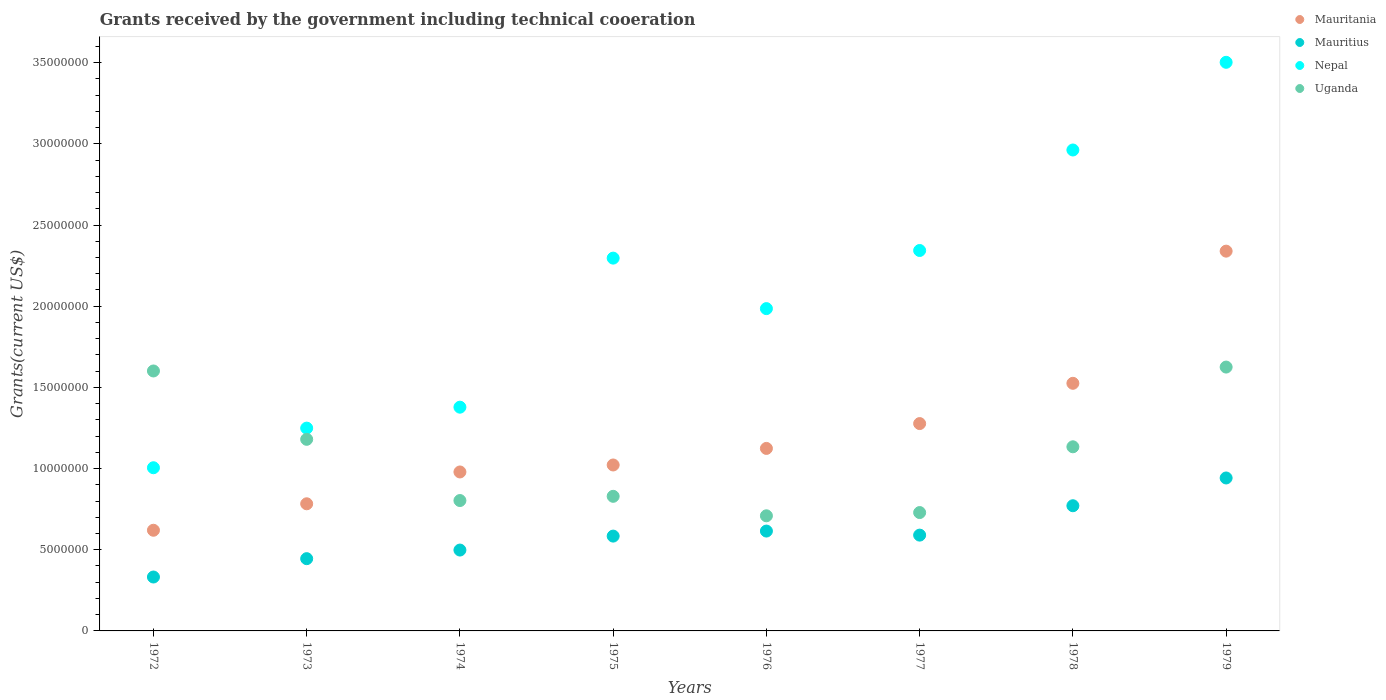What is the total grants received by the government in Nepal in 1973?
Keep it short and to the point. 1.25e+07. Across all years, what is the maximum total grants received by the government in Mauritania?
Provide a succinct answer. 2.34e+07. Across all years, what is the minimum total grants received by the government in Nepal?
Your response must be concise. 1.00e+07. In which year was the total grants received by the government in Uganda maximum?
Your response must be concise. 1979. In which year was the total grants received by the government in Uganda minimum?
Keep it short and to the point. 1976. What is the total total grants received by the government in Uganda in the graph?
Your answer should be compact. 8.61e+07. What is the difference between the total grants received by the government in Mauritius in 1974 and that in 1977?
Your answer should be compact. -9.20e+05. What is the difference between the total grants received by the government in Mauritania in 1979 and the total grants received by the government in Mauritius in 1975?
Ensure brevity in your answer.  1.76e+07. What is the average total grants received by the government in Mauritania per year?
Make the answer very short. 1.21e+07. In the year 1972, what is the difference between the total grants received by the government in Mauritania and total grants received by the government in Mauritius?
Your answer should be very brief. 2.88e+06. What is the ratio of the total grants received by the government in Mauritius in 1975 to that in 1978?
Ensure brevity in your answer.  0.76. Is the total grants received by the government in Nepal in 1972 less than that in 1977?
Ensure brevity in your answer.  Yes. What is the difference between the highest and the second highest total grants received by the government in Nepal?
Give a very brief answer. 5.40e+06. What is the difference between the highest and the lowest total grants received by the government in Mauritius?
Offer a terse response. 6.10e+06. Is the sum of the total grants received by the government in Mauritania in 1976 and 1978 greater than the maximum total grants received by the government in Mauritius across all years?
Give a very brief answer. Yes. Is it the case that in every year, the sum of the total grants received by the government in Mauritania and total grants received by the government in Mauritius  is greater than the total grants received by the government in Uganda?
Give a very brief answer. No. Does the total grants received by the government in Mauritius monotonically increase over the years?
Offer a very short reply. No. Is the total grants received by the government in Mauritania strictly less than the total grants received by the government in Nepal over the years?
Ensure brevity in your answer.  Yes. How many dotlines are there?
Provide a short and direct response. 4. How many years are there in the graph?
Your answer should be compact. 8. Are the values on the major ticks of Y-axis written in scientific E-notation?
Offer a terse response. No. Does the graph contain any zero values?
Make the answer very short. No. Does the graph contain grids?
Your answer should be very brief. No. Where does the legend appear in the graph?
Offer a terse response. Top right. How many legend labels are there?
Provide a short and direct response. 4. What is the title of the graph?
Your answer should be compact. Grants received by the government including technical cooeration. Does "Low & middle income" appear as one of the legend labels in the graph?
Your answer should be compact. No. What is the label or title of the X-axis?
Offer a terse response. Years. What is the label or title of the Y-axis?
Your answer should be compact. Grants(current US$). What is the Grants(current US$) of Mauritania in 1972?
Offer a very short reply. 6.20e+06. What is the Grants(current US$) of Mauritius in 1972?
Give a very brief answer. 3.32e+06. What is the Grants(current US$) in Nepal in 1972?
Your response must be concise. 1.00e+07. What is the Grants(current US$) in Uganda in 1972?
Give a very brief answer. 1.60e+07. What is the Grants(current US$) of Mauritania in 1973?
Provide a succinct answer. 7.83e+06. What is the Grants(current US$) in Mauritius in 1973?
Offer a very short reply. 4.45e+06. What is the Grants(current US$) of Nepal in 1973?
Provide a short and direct response. 1.25e+07. What is the Grants(current US$) in Uganda in 1973?
Offer a terse response. 1.18e+07. What is the Grants(current US$) in Mauritania in 1974?
Offer a terse response. 9.79e+06. What is the Grants(current US$) in Mauritius in 1974?
Ensure brevity in your answer.  4.98e+06. What is the Grants(current US$) in Nepal in 1974?
Ensure brevity in your answer.  1.38e+07. What is the Grants(current US$) in Uganda in 1974?
Your answer should be compact. 8.03e+06. What is the Grants(current US$) of Mauritania in 1975?
Your answer should be very brief. 1.02e+07. What is the Grants(current US$) in Mauritius in 1975?
Keep it short and to the point. 5.84e+06. What is the Grants(current US$) in Nepal in 1975?
Your answer should be very brief. 2.30e+07. What is the Grants(current US$) of Uganda in 1975?
Your answer should be compact. 8.29e+06. What is the Grants(current US$) in Mauritania in 1976?
Provide a succinct answer. 1.12e+07. What is the Grants(current US$) in Mauritius in 1976?
Provide a short and direct response. 6.15e+06. What is the Grants(current US$) in Nepal in 1976?
Offer a very short reply. 1.98e+07. What is the Grants(current US$) in Uganda in 1976?
Ensure brevity in your answer.  7.09e+06. What is the Grants(current US$) in Mauritania in 1977?
Your answer should be very brief. 1.28e+07. What is the Grants(current US$) in Mauritius in 1977?
Your answer should be very brief. 5.90e+06. What is the Grants(current US$) in Nepal in 1977?
Give a very brief answer. 2.34e+07. What is the Grants(current US$) of Uganda in 1977?
Offer a very short reply. 7.29e+06. What is the Grants(current US$) of Mauritania in 1978?
Offer a very short reply. 1.52e+07. What is the Grants(current US$) of Mauritius in 1978?
Provide a short and direct response. 7.71e+06. What is the Grants(current US$) in Nepal in 1978?
Offer a terse response. 2.96e+07. What is the Grants(current US$) of Uganda in 1978?
Provide a short and direct response. 1.13e+07. What is the Grants(current US$) of Mauritania in 1979?
Give a very brief answer. 2.34e+07. What is the Grants(current US$) in Mauritius in 1979?
Provide a succinct answer. 9.42e+06. What is the Grants(current US$) in Nepal in 1979?
Make the answer very short. 3.50e+07. What is the Grants(current US$) of Uganda in 1979?
Provide a short and direct response. 1.62e+07. Across all years, what is the maximum Grants(current US$) of Mauritania?
Give a very brief answer. 2.34e+07. Across all years, what is the maximum Grants(current US$) of Mauritius?
Your answer should be very brief. 9.42e+06. Across all years, what is the maximum Grants(current US$) in Nepal?
Offer a very short reply. 3.50e+07. Across all years, what is the maximum Grants(current US$) of Uganda?
Provide a short and direct response. 1.62e+07. Across all years, what is the minimum Grants(current US$) of Mauritania?
Keep it short and to the point. 6.20e+06. Across all years, what is the minimum Grants(current US$) of Mauritius?
Give a very brief answer. 3.32e+06. Across all years, what is the minimum Grants(current US$) of Nepal?
Provide a short and direct response. 1.00e+07. Across all years, what is the minimum Grants(current US$) in Uganda?
Keep it short and to the point. 7.09e+06. What is the total Grants(current US$) in Mauritania in the graph?
Ensure brevity in your answer.  9.67e+07. What is the total Grants(current US$) of Mauritius in the graph?
Your answer should be compact. 4.78e+07. What is the total Grants(current US$) in Nepal in the graph?
Provide a succinct answer. 1.67e+08. What is the total Grants(current US$) of Uganda in the graph?
Your response must be concise. 8.61e+07. What is the difference between the Grants(current US$) in Mauritania in 1972 and that in 1973?
Ensure brevity in your answer.  -1.63e+06. What is the difference between the Grants(current US$) of Mauritius in 1972 and that in 1973?
Offer a terse response. -1.13e+06. What is the difference between the Grants(current US$) of Nepal in 1972 and that in 1973?
Keep it short and to the point. -2.44e+06. What is the difference between the Grants(current US$) in Uganda in 1972 and that in 1973?
Offer a terse response. 4.21e+06. What is the difference between the Grants(current US$) in Mauritania in 1972 and that in 1974?
Ensure brevity in your answer.  -3.59e+06. What is the difference between the Grants(current US$) of Mauritius in 1972 and that in 1974?
Your answer should be compact. -1.66e+06. What is the difference between the Grants(current US$) of Nepal in 1972 and that in 1974?
Keep it short and to the point. -3.73e+06. What is the difference between the Grants(current US$) in Uganda in 1972 and that in 1974?
Your answer should be compact. 7.98e+06. What is the difference between the Grants(current US$) of Mauritania in 1972 and that in 1975?
Give a very brief answer. -4.02e+06. What is the difference between the Grants(current US$) of Mauritius in 1972 and that in 1975?
Offer a terse response. -2.52e+06. What is the difference between the Grants(current US$) in Nepal in 1972 and that in 1975?
Give a very brief answer. -1.29e+07. What is the difference between the Grants(current US$) of Uganda in 1972 and that in 1975?
Provide a succinct answer. 7.72e+06. What is the difference between the Grants(current US$) in Mauritania in 1972 and that in 1976?
Offer a very short reply. -5.04e+06. What is the difference between the Grants(current US$) of Mauritius in 1972 and that in 1976?
Provide a succinct answer. -2.83e+06. What is the difference between the Grants(current US$) in Nepal in 1972 and that in 1976?
Offer a terse response. -9.80e+06. What is the difference between the Grants(current US$) of Uganda in 1972 and that in 1976?
Offer a very short reply. 8.92e+06. What is the difference between the Grants(current US$) of Mauritania in 1972 and that in 1977?
Your answer should be compact. -6.57e+06. What is the difference between the Grants(current US$) of Mauritius in 1972 and that in 1977?
Give a very brief answer. -2.58e+06. What is the difference between the Grants(current US$) in Nepal in 1972 and that in 1977?
Provide a short and direct response. -1.34e+07. What is the difference between the Grants(current US$) in Uganda in 1972 and that in 1977?
Your answer should be compact. 8.72e+06. What is the difference between the Grants(current US$) in Mauritania in 1972 and that in 1978?
Give a very brief answer. -9.05e+06. What is the difference between the Grants(current US$) in Mauritius in 1972 and that in 1978?
Your answer should be compact. -4.39e+06. What is the difference between the Grants(current US$) in Nepal in 1972 and that in 1978?
Your answer should be compact. -1.96e+07. What is the difference between the Grants(current US$) of Uganda in 1972 and that in 1978?
Your answer should be very brief. 4.67e+06. What is the difference between the Grants(current US$) in Mauritania in 1972 and that in 1979?
Ensure brevity in your answer.  -1.72e+07. What is the difference between the Grants(current US$) of Mauritius in 1972 and that in 1979?
Keep it short and to the point. -6.10e+06. What is the difference between the Grants(current US$) in Nepal in 1972 and that in 1979?
Your answer should be compact. -2.50e+07. What is the difference between the Grants(current US$) in Uganda in 1972 and that in 1979?
Your answer should be very brief. -2.40e+05. What is the difference between the Grants(current US$) in Mauritania in 1973 and that in 1974?
Make the answer very short. -1.96e+06. What is the difference between the Grants(current US$) of Mauritius in 1973 and that in 1974?
Offer a terse response. -5.30e+05. What is the difference between the Grants(current US$) of Nepal in 1973 and that in 1974?
Your answer should be compact. -1.29e+06. What is the difference between the Grants(current US$) of Uganda in 1973 and that in 1974?
Offer a very short reply. 3.77e+06. What is the difference between the Grants(current US$) of Mauritania in 1973 and that in 1975?
Offer a very short reply. -2.39e+06. What is the difference between the Grants(current US$) of Mauritius in 1973 and that in 1975?
Provide a succinct answer. -1.39e+06. What is the difference between the Grants(current US$) of Nepal in 1973 and that in 1975?
Keep it short and to the point. -1.05e+07. What is the difference between the Grants(current US$) in Uganda in 1973 and that in 1975?
Provide a short and direct response. 3.51e+06. What is the difference between the Grants(current US$) of Mauritania in 1973 and that in 1976?
Make the answer very short. -3.41e+06. What is the difference between the Grants(current US$) of Mauritius in 1973 and that in 1976?
Your answer should be very brief. -1.70e+06. What is the difference between the Grants(current US$) in Nepal in 1973 and that in 1976?
Offer a terse response. -7.36e+06. What is the difference between the Grants(current US$) in Uganda in 1973 and that in 1976?
Provide a succinct answer. 4.71e+06. What is the difference between the Grants(current US$) of Mauritania in 1973 and that in 1977?
Provide a succinct answer. -4.94e+06. What is the difference between the Grants(current US$) of Mauritius in 1973 and that in 1977?
Keep it short and to the point. -1.45e+06. What is the difference between the Grants(current US$) of Nepal in 1973 and that in 1977?
Your response must be concise. -1.09e+07. What is the difference between the Grants(current US$) of Uganda in 1973 and that in 1977?
Your answer should be compact. 4.51e+06. What is the difference between the Grants(current US$) of Mauritania in 1973 and that in 1978?
Give a very brief answer. -7.42e+06. What is the difference between the Grants(current US$) of Mauritius in 1973 and that in 1978?
Your response must be concise. -3.26e+06. What is the difference between the Grants(current US$) in Nepal in 1973 and that in 1978?
Offer a very short reply. -1.71e+07. What is the difference between the Grants(current US$) in Uganda in 1973 and that in 1978?
Offer a terse response. 4.60e+05. What is the difference between the Grants(current US$) in Mauritania in 1973 and that in 1979?
Provide a short and direct response. -1.56e+07. What is the difference between the Grants(current US$) in Mauritius in 1973 and that in 1979?
Keep it short and to the point. -4.97e+06. What is the difference between the Grants(current US$) in Nepal in 1973 and that in 1979?
Keep it short and to the point. -2.25e+07. What is the difference between the Grants(current US$) of Uganda in 1973 and that in 1979?
Provide a short and direct response. -4.45e+06. What is the difference between the Grants(current US$) of Mauritania in 1974 and that in 1975?
Your response must be concise. -4.30e+05. What is the difference between the Grants(current US$) of Mauritius in 1974 and that in 1975?
Offer a very short reply. -8.60e+05. What is the difference between the Grants(current US$) in Nepal in 1974 and that in 1975?
Give a very brief answer. -9.18e+06. What is the difference between the Grants(current US$) in Mauritania in 1974 and that in 1976?
Your answer should be compact. -1.45e+06. What is the difference between the Grants(current US$) in Mauritius in 1974 and that in 1976?
Offer a very short reply. -1.17e+06. What is the difference between the Grants(current US$) of Nepal in 1974 and that in 1976?
Offer a terse response. -6.07e+06. What is the difference between the Grants(current US$) of Uganda in 1974 and that in 1976?
Keep it short and to the point. 9.40e+05. What is the difference between the Grants(current US$) in Mauritania in 1974 and that in 1977?
Provide a short and direct response. -2.98e+06. What is the difference between the Grants(current US$) of Mauritius in 1974 and that in 1977?
Ensure brevity in your answer.  -9.20e+05. What is the difference between the Grants(current US$) of Nepal in 1974 and that in 1977?
Provide a short and direct response. -9.65e+06. What is the difference between the Grants(current US$) in Uganda in 1974 and that in 1977?
Offer a terse response. 7.40e+05. What is the difference between the Grants(current US$) in Mauritania in 1974 and that in 1978?
Give a very brief answer. -5.46e+06. What is the difference between the Grants(current US$) in Mauritius in 1974 and that in 1978?
Offer a terse response. -2.73e+06. What is the difference between the Grants(current US$) of Nepal in 1974 and that in 1978?
Your response must be concise. -1.58e+07. What is the difference between the Grants(current US$) in Uganda in 1974 and that in 1978?
Your response must be concise. -3.31e+06. What is the difference between the Grants(current US$) in Mauritania in 1974 and that in 1979?
Your answer should be very brief. -1.36e+07. What is the difference between the Grants(current US$) in Mauritius in 1974 and that in 1979?
Your answer should be compact. -4.44e+06. What is the difference between the Grants(current US$) of Nepal in 1974 and that in 1979?
Offer a terse response. -2.12e+07. What is the difference between the Grants(current US$) of Uganda in 1974 and that in 1979?
Offer a terse response. -8.22e+06. What is the difference between the Grants(current US$) in Mauritania in 1975 and that in 1976?
Provide a succinct answer. -1.02e+06. What is the difference between the Grants(current US$) in Mauritius in 1975 and that in 1976?
Make the answer very short. -3.10e+05. What is the difference between the Grants(current US$) of Nepal in 1975 and that in 1976?
Your response must be concise. 3.11e+06. What is the difference between the Grants(current US$) in Uganda in 1975 and that in 1976?
Ensure brevity in your answer.  1.20e+06. What is the difference between the Grants(current US$) of Mauritania in 1975 and that in 1977?
Offer a very short reply. -2.55e+06. What is the difference between the Grants(current US$) in Mauritius in 1975 and that in 1977?
Give a very brief answer. -6.00e+04. What is the difference between the Grants(current US$) of Nepal in 1975 and that in 1977?
Provide a succinct answer. -4.70e+05. What is the difference between the Grants(current US$) in Uganda in 1975 and that in 1977?
Provide a short and direct response. 1.00e+06. What is the difference between the Grants(current US$) of Mauritania in 1975 and that in 1978?
Offer a terse response. -5.03e+06. What is the difference between the Grants(current US$) of Mauritius in 1975 and that in 1978?
Offer a terse response. -1.87e+06. What is the difference between the Grants(current US$) of Nepal in 1975 and that in 1978?
Make the answer very short. -6.66e+06. What is the difference between the Grants(current US$) of Uganda in 1975 and that in 1978?
Your answer should be very brief. -3.05e+06. What is the difference between the Grants(current US$) of Mauritania in 1975 and that in 1979?
Offer a very short reply. -1.32e+07. What is the difference between the Grants(current US$) in Mauritius in 1975 and that in 1979?
Ensure brevity in your answer.  -3.58e+06. What is the difference between the Grants(current US$) in Nepal in 1975 and that in 1979?
Your answer should be very brief. -1.21e+07. What is the difference between the Grants(current US$) in Uganda in 1975 and that in 1979?
Your answer should be very brief. -7.96e+06. What is the difference between the Grants(current US$) in Mauritania in 1976 and that in 1977?
Provide a succinct answer. -1.53e+06. What is the difference between the Grants(current US$) of Nepal in 1976 and that in 1977?
Ensure brevity in your answer.  -3.58e+06. What is the difference between the Grants(current US$) of Mauritania in 1976 and that in 1978?
Provide a short and direct response. -4.01e+06. What is the difference between the Grants(current US$) of Mauritius in 1976 and that in 1978?
Offer a terse response. -1.56e+06. What is the difference between the Grants(current US$) in Nepal in 1976 and that in 1978?
Offer a very short reply. -9.77e+06. What is the difference between the Grants(current US$) of Uganda in 1976 and that in 1978?
Your response must be concise. -4.25e+06. What is the difference between the Grants(current US$) in Mauritania in 1976 and that in 1979?
Give a very brief answer. -1.22e+07. What is the difference between the Grants(current US$) of Mauritius in 1976 and that in 1979?
Your answer should be very brief. -3.27e+06. What is the difference between the Grants(current US$) of Nepal in 1976 and that in 1979?
Provide a short and direct response. -1.52e+07. What is the difference between the Grants(current US$) of Uganda in 1976 and that in 1979?
Your response must be concise. -9.16e+06. What is the difference between the Grants(current US$) in Mauritania in 1977 and that in 1978?
Your answer should be very brief. -2.48e+06. What is the difference between the Grants(current US$) in Mauritius in 1977 and that in 1978?
Your answer should be compact. -1.81e+06. What is the difference between the Grants(current US$) in Nepal in 1977 and that in 1978?
Offer a very short reply. -6.19e+06. What is the difference between the Grants(current US$) in Uganda in 1977 and that in 1978?
Your answer should be compact. -4.05e+06. What is the difference between the Grants(current US$) in Mauritania in 1977 and that in 1979?
Offer a terse response. -1.06e+07. What is the difference between the Grants(current US$) of Mauritius in 1977 and that in 1979?
Keep it short and to the point. -3.52e+06. What is the difference between the Grants(current US$) of Nepal in 1977 and that in 1979?
Your answer should be very brief. -1.16e+07. What is the difference between the Grants(current US$) of Uganda in 1977 and that in 1979?
Provide a short and direct response. -8.96e+06. What is the difference between the Grants(current US$) in Mauritania in 1978 and that in 1979?
Offer a terse response. -8.14e+06. What is the difference between the Grants(current US$) in Mauritius in 1978 and that in 1979?
Ensure brevity in your answer.  -1.71e+06. What is the difference between the Grants(current US$) of Nepal in 1978 and that in 1979?
Your answer should be very brief. -5.40e+06. What is the difference between the Grants(current US$) in Uganda in 1978 and that in 1979?
Provide a succinct answer. -4.91e+06. What is the difference between the Grants(current US$) of Mauritania in 1972 and the Grants(current US$) of Mauritius in 1973?
Offer a very short reply. 1.75e+06. What is the difference between the Grants(current US$) in Mauritania in 1972 and the Grants(current US$) in Nepal in 1973?
Make the answer very short. -6.29e+06. What is the difference between the Grants(current US$) of Mauritania in 1972 and the Grants(current US$) of Uganda in 1973?
Your answer should be very brief. -5.60e+06. What is the difference between the Grants(current US$) in Mauritius in 1972 and the Grants(current US$) in Nepal in 1973?
Give a very brief answer. -9.17e+06. What is the difference between the Grants(current US$) of Mauritius in 1972 and the Grants(current US$) of Uganda in 1973?
Your answer should be very brief. -8.48e+06. What is the difference between the Grants(current US$) of Nepal in 1972 and the Grants(current US$) of Uganda in 1973?
Your answer should be compact. -1.75e+06. What is the difference between the Grants(current US$) in Mauritania in 1972 and the Grants(current US$) in Mauritius in 1974?
Provide a succinct answer. 1.22e+06. What is the difference between the Grants(current US$) in Mauritania in 1972 and the Grants(current US$) in Nepal in 1974?
Offer a terse response. -7.58e+06. What is the difference between the Grants(current US$) of Mauritania in 1972 and the Grants(current US$) of Uganda in 1974?
Your answer should be very brief. -1.83e+06. What is the difference between the Grants(current US$) in Mauritius in 1972 and the Grants(current US$) in Nepal in 1974?
Give a very brief answer. -1.05e+07. What is the difference between the Grants(current US$) of Mauritius in 1972 and the Grants(current US$) of Uganda in 1974?
Give a very brief answer. -4.71e+06. What is the difference between the Grants(current US$) in Nepal in 1972 and the Grants(current US$) in Uganda in 1974?
Provide a short and direct response. 2.02e+06. What is the difference between the Grants(current US$) of Mauritania in 1972 and the Grants(current US$) of Mauritius in 1975?
Your answer should be compact. 3.60e+05. What is the difference between the Grants(current US$) in Mauritania in 1972 and the Grants(current US$) in Nepal in 1975?
Your answer should be compact. -1.68e+07. What is the difference between the Grants(current US$) of Mauritania in 1972 and the Grants(current US$) of Uganda in 1975?
Keep it short and to the point. -2.09e+06. What is the difference between the Grants(current US$) in Mauritius in 1972 and the Grants(current US$) in Nepal in 1975?
Your response must be concise. -1.96e+07. What is the difference between the Grants(current US$) of Mauritius in 1972 and the Grants(current US$) of Uganda in 1975?
Offer a terse response. -4.97e+06. What is the difference between the Grants(current US$) in Nepal in 1972 and the Grants(current US$) in Uganda in 1975?
Ensure brevity in your answer.  1.76e+06. What is the difference between the Grants(current US$) in Mauritania in 1972 and the Grants(current US$) in Mauritius in 1976?
Provide a succinct answer. 5.00e+04. What is the difference between the Grants(current US$) of Mauritania in 1972 and the Grants(current US$) of Nepal in 1976?
Make the answer very short. -1.36e+07. What is the difference between the Grants(current US$) of Mauritania in 1972 and the Grants(current US$) of Uganda in 1976?
Provide a succinct answer. -8.90e+05. What is the difference between the Grants(current US$) of Mauritius in 1972 and the Grants(current US$) of Nepal in 1976?
Offer a terse response. -1.65e+07. What is the difference between the Grants(current US$) in Mauritius in 1972 and the Grants(current US$) in Uganda in 1976?
Offer a terse response. -3.77e+06. What is the difference between the Grants(current US$) in Nepal in 1972 and the Grants(current US$) in Uganda in 1976?
Your response must be concise. 2.96e+06. What is the difference between the Grants(current US$) in Mauritania in 1972 and the Grants(current US$) in Nepal in 1977?
Give a very brief answer. -1.72e+07. What is the difference between the Grants(current US$) in Mauritania in 1972 and the Grants(current US$) in Uganda in 1977?
Ensure brevity in your answer.  -1.09e+06. What is the difference between the Grants(current US$) of Mauritius in 1972 and the Grants(current US$) of Nepal in 1977?
Your answer should be very brief. -2.01e+07. What is the difference between the Grants(current US$) in Mauritius in 1972 and the Grants(current US$) in Uganda in 1977?
Keep it short and to the point. -3.97e+06. What is the difference between the Grants(current US$) of Nepal in 1972 and the Grants(current US$) of Uganda in 1977?
Your answer should be compact. 2.76e+06. What is the difference between the Grants(current US$) of Mauritania in 1972 and the Grants(current US$) of Mauritius in 1978?
Offer a terse response. -1.51e+06. What is the difference between the Grants(current US$) in Mauritania in 1972 and the Grants(current US$) in Nepal in 1978?
Keep it short and to the point. -2.34e+07. What is the difference between the Grants(current US$) in Mauritania in 1972 and the Grants(current US$) in Uganda in 1978?
Provide a short and direct response. -5.14e+06. What is the difference between the Grants(current US$) in Mauritius in 1972 and the Grants(current US$) in Nepal in 1978?
Your answer should be very brief. -2.63e+07. What is the difference between the Grants(current US$) in Mauritius in 1972 and the Grants(current US$) in Uganda in 1978?
Offer a terse response. -8.02e+06. What is the difference between the Grants(current US$) in Nepal in 1972 and the Grants(current US$) in Uganda in 1978?
Your answer should be very brief. -1.29e+06. What is the difference between the Grants(current US$) of Mauritania in 1972 and the Grants(current US$) of Mauritius in 1979?
Ensure brevity in your answer.  -3.22e+06. What is the difference between the Grants(current US$) in Mauritania in 1972 and the Grants(current US$) in Nepal in 1979?
Give a very brief answer. -2.88e+07. What is the difference between the Grants(current US$) in Mauritania in 1972 and the Grants(current US$) in Uganda in 1979?
Your answer should be compact. -1.00e+07. What is the difference between the Grants(current US$) in Mauritius in 1972 and the Grants(current US$) in Nepal in 1979?
Ensure brevity in your answer.  -3.17e+07. What is the difference between the Grants(current US$) of Mauritius in 1972 and the Grants(current US$) of Uganda in 1979?
Your answer should be compact. -1.29e+07. What is the difference between the Grants(current US$) of Nepal in 1972 and the Grants(current US$) of Uganda in 1979?
Your response must be concise. -6.20e+06. What is the difference between the Grants(current US$) of Mauritania in 1973 and the Grants(current US$) of Mauritius in 1974?
Your answer should be compact. 2.85e+06. What is the difference between the Grants(current US$) of Mauritania in 1973 and the Grants(current US$) of Nepal in 1974?
Offer a terse response. -5.95e+06. What is the difference between the Grants(current US$) of Mauritius in 1973 and the Grants(current US$) of Nepal in 1974?
Your answer should be compact. -9.33e+06. What is the difference between the Grants(current US$) of Mauritius in 1973 and the Grants(current US$) of Uganda in 1974?
Provide a short and direct response. -3.58e+06. What is the difference between the Grants(current US$) of Nepal in 1973 and the Grants(current US$) of Uganda in 1974?
Offer a terse response. 4.46e+06. What is the difference between the Grants(current US$) of Mauritania in 1973 and the Grants(current US$) of Mauritius in 1975?
Provide a short and direct response. 1.99e+06. What is the difference between the Grants(current US$) in Mauritania in 1973 and the Grants(current US$) in Nepal in 1975?
Your answer should be very brief. -1.51e+07. What is the difference between the Grants(current US$) in Mauritania in 1973 and the Grants(current US$) in Uganda in 1975?
Provide a succinct answer. -4.60e+05. What is the difference between the Grants(current US$) in Mauritius in 1973 and the Grants(current US$) in Nepal in 1975?
Ensure brevity in your answer.  -1.85e+07. What is the difference between the Grants(current US$) of Mauritius in 1973 and the Grants(current US$) of Uganda in 1975?
Provide a short and direct response. -3.84e+06. What is the difference between the Grants(current US$) in Nepal in 1973 and the Grants(current US$) in Uganda in 1975?
Offer a very short reply. 4.20e+06. What is the difference between the Grants(current US$) of Mauritania in 1973 and the Grants(current US$) of Mauritius in 1976?
Provide a short and direct response. 1.68e+06. What is the difference between the Grants(current US$) in Mauritania in 1973 and the Grants(current US$) in Nepal in 1976?
Make the answer very short. -1.20e+07. What is the difference between the Grants(current US$) of Mauritania in 1973 and the Grants(current US$) of Uganda in 1976?
Your response must be concise. 7.40e+05. What is the difference between the Grants(current US$) of Mauritius in 1973 and the Grants(current US$) of Nepal in 1976?
Your answer should be very brief. -1.54e+07. What is the difference between the Grants(current US$) in Mauritius in 1973 and the Grants(current US$) in Uganda in 1976?
Ensure brevity in your answer.  -2.64e+06. What is the difference between the Grants(current US$) of Nepal in 1973 and the Grants(current US$) of Uganda in 1976?
Make the answer very short. 5.40e+06. What is the difference between the Grants(current US$) of Mauritania in 1973 and the Grants(current US$) of Mauritius in 1977?
Your response must be concise. 1.93e+06. What is the difference between the Grants(current US$) in Mauritania in 1973 and the Grants(current US$) in Nepal in 1977?
Your answer should be compact. -1.56e+07. What is the difference between the Grants(current US$) in Mauritania in 1973 and the Grants(current US$) in Uganda in 1977?
Offer a terse response. 5.40e+05. What is the difference between the Grants(current US$) in Mauritius in 1973 and the Grants(current US$) in Nepal in 1977?
Offer a very short reply. -1.90e+07. What is the difference between the Grants(current US$) of Mauritius in 1973 and the Grants(current US$) of Uganda in 1977?
Offer a terse response. -2.84e+06. What is the difference between the Grants(current US$) in Nepal in 1973 and the Grants(current US$) in Uganda in 1977?
Your response must be concise. 5.20e+06. What is the difference between the Grants(current US$) of Mauritania in 1973 and the Grants(current US$) of Nepal in 1978?
Offer a very short reply. -2.18e+07. What is the difference between the Grants(current US$) in Mauritania in 1973 and the Grants(current US$) in Uganda in 1978?
Provide a succinct answer. -3.51e+06. What is the difference between the Grants(current US$) of Mauritius in 1973 and the Grants(current US$) of Nepal in 1978?
Your response must be concise. -2.52e+07. What is the difference between the Grants(current US$) of Mauritius in 1973 and the Grants(current US$) of Uganda in 1978?
Provide a short and direct response. -6.89e+06. What is the difference between the Grants(current US$) of Nepal in 1973 and the Grants(current US$) of Uganda in 1978?
Provide a short and direct response. 1.15e+06. What is the difference between the Grants(current US$) in Mauritania in 1973 and the Grants(current US$) in Mauritius in 1979?
Give a very brief answer. -1.59e+06. What is the difference between the Grants(current US$) of Mauritania in 1973 and the Grants(current US$) of Nepal in 1979?
Your answer should be very brief. -2.72e+07. What is the difference between the Grants(current US$) of Mauritania in 1973 and the Grants(current US$) of Uganda in 1979?
Offer a very short reply. -8.42e+06. What is the difference between the Grants(current US$) in Mauritius in 1973 and the Grants(current US$) in Nepal in 1979?
Offer a very short reply. -3.06e+07. What is the difference between the Grants(current US$) of Mauritius in 1973 and the Grants(current US$) of Uganda in 1979?
Make the answer very short. -1.18e+07. What is the difference between the Grants(current US$) of Nepal in 1973 and the Grants(current US$) of Uganda in 1979?
Keep it short and to the point. -3.76e+06. What is the difference between the Grants(current US$) of Mauritania in 1974 and the Grants(current US$) of Mauritius in 1975?
Your answer should be very brief. 3.95e+06. What is the difference between the Grants(current US$) in Mauritania in 1974 and the Grants(current US$) in Nepal in 1975?
Offer a terse response. -1.32e+07. What is the difference between the Grants(current US$) in Mauritania in 1974 and the Grants(current US$) in Uganda in 1975?
Offer a very short reply. 1.50e+06. What is the difference between the Grants(current US$) of Mauritius in 1974 and the Grants(current US$) of Nepal in 1975?
Ensure brevity in your answer.  -1.80e+07. What is the difference between the Grants(current US$) of Mauritius in 1974 and the Grants(current US$) of Uganda in 1975?
Provide a succinct answer. -3.31e+06. What is the difference between the Grants(current US$) of Nepal in 1974 and the Grants(current US$) of Uganda in 1975?
Your response must be concise. 5.49e+06. What is the difference between the Grants(current US$) of Mauritania in 1974 and the Grants(current US$) of Mauritius in 1976?
Keep it short and to the point. 3.64e+06. What is the difference between the Grants(current US$) of Mauritania in 1974 and the Grants(current US$) of Nepal in 1976?
Your response must be concise. -1.01e+07. What is the difference between the Grants(current US$) in Mauritania in 1974 and the Grants(current US$) in Uganda in 1976?
Your response must be concise. 2.70e+06. What is the difference between the Grants(current US$) of Mauritius in 1974 and the Grants(current US$) of Nepal in 1976?
Make the answer very short. -1.49e+07. What is the difference between the Grants(current US$) in Mauritius in 1974 and the Grants(current US$) in Uganda in 1976?
Provide a short and direct response. -2.11e+06. What is the difference between the Grants(current US$) in Nepal in 1974 and the Grants(current US$) in Uganda in 1976?
Give a very brief answer. 6.69e+06. What is the difference between the Grants(current US$) of Mauritania in 1974 and the Grants(current US$) of Mauritius in 1977?
Your answer should be very brief. 3.89e+06. What is the difference between the Grants(current US$) in Mauritania in 1974 and the Grants(current US$) in Nepal in 1977?
Make the answer very short. -1.36e+07. What is the difference between the Grants(current US$) in Mauritania in 1974 and the Grants(current US$) in Uganda in 1977?
Your answer should be compact. 2.50e+06. What is the difference between the Grants(current US$) of Mauritius in 1974 and the Grants(current US$) of Nepal in 1977?
Your answer should be compact. -1.84e+07. What is the difference between the Grants(current US$) in Mauritius in 1974 and the Grants(current US$) in Uganda in 1977?
Keep it short and to the point. -2.31e+06. What is the difference between the Grants(current US$) in Nepal in 1974 and the Grants(current US$) in Uganda in 1977?
Offer a terse response. 6.49e+06. What is the difference between the Grants(current US$) in Mauritania in 1974 and the Grants(current US$) in Mauritius in 1978?
Your answer should be compact. 2.08e+06. What is the difference between the Grants(current US$) of Mauritania in 1974 and the Grants(current US$) of Nepal in 1978?
Offer a very short reply. -1.98e+07. What is the difference between the Grants(current US$) of Mauritania in 1974 and the Grants(current US$) of Uganda in 1978?
Your answer should be very brief. -1.55e+06. What is the difference between the Grants(current US$) in Mauritius in 1974 and the Grants(current US$) in Nepal in 1978?
Your response must be concise. -2.46e+07. What is the difference between the Grants(current US$) of Mauritius in 1974 and the Grants(current US$) of Uganda in 1978?
Make the answer very short. -6.36e+06. What is the difference between the Grants(current US$) in Nepal in 1974 and the Grants(current US$) in Uganda in 1978?
Keep it short and to the point. 2.44e+06. What is the difference between the Grants(current US$) in Mauritania in 1974 and the Grants(current US$) in Mauritius in 1979?
Offer a terse response. 3.70e+05. What is the difference between the Grants(current US$) of Mauritania in 1974 and the Grants(current US$) of Nepal in 1979?
Offer a very short reply. -2.52e+07. What is the difference between the Grants(current US$) of Mauritania in 1974 and the Grants(current US$) of Uganda in 1979?
Make the answer very short. -6.46e+06. What is the difference between the Grants(current US$) in Mauritius in 1974 and the Grants(current US$) in Nepal in 1979?
Offer a terse response. -3.00e+07. What is the difference between the Grants(current US$) in Mauritius in 1974 and the Grants(current US$) in Uganda in 1979?
Give a very brief answer. -1.13e+07. What is the difference between the Grants(current US$) in Nepal in 1974 and the Grants(current US$) in Uganda in 1979?
Keep it short and to the point. -2.47e+06. What is the difference between the Grants(current US$) of Mauritania in 1975 and the Grants(current US$) of Mauritius in 1976?
Your answer should be compact. 4.07e+06. What is the difference between the Grants(current US$) of Mauritania in 1975 and the Grants(current US$) of Nepal in 1976?
Keep it short and to the point. -9.63e+06. What is the difference between the Grants(current US$) of Mauritania in 1975 and the Grants(current US$) of Uganda in 1976?
Keep it short and to the point. 3.13e+06. What is the difference between the Grants(current US$) in Mauritius in 1975 and the Grants(current US$) in Nepal in 1976?
Offer a very short reply. -1.40e+07. What is the difference between the Grants(current US$) in Mauritius in 1975 and the Grants(current US$) in Uganda in 1976?
Give a very brief answer. -1.25e+06. What is the difference between the Grants(current US$) in Nepal in 1975 and the Grants(current US$) in Uganda in 1976?
Provide a succinct answer. 1.59e+07. What is the difference between the Grants(current US$) of Mauritania in 1975 and the Grants(current US$) of Mauritius in 1977?
Make the answer very short. 4.32e+06. What is the difference between the Grants(current US$) in Mauritania in 1975 and the Grants(current US$) in Nepal in 1977?
Provide a succinct answer. -1.32e+07. What is the difference between the Grants(current US$) of Mauritania in 1975 and the Grants(current US$) of Uganda in 1977?
Provide a short and direct response. 2.93e+06. What is the difference between the Grants(current US$) in Mauritius in 1975 and the Grants(current US$) in Nepal in 1977?
Ensure brevity in your answer.  -1.76e+07. What is the difference between the Grants(current US$) of Mauritius in 1975 and the Grants(current US$) of Uganda in 1977?
Provide a succinct answer. -1.45e+06. What is the difference between the Grants(current US$) in Nepal in 1975 and the Grants(current US$) in Uganda in 1977?
Provide a short and direct response. 1.57e+07. What is the difference between the Grants(current US$) in Mauritania in 1975 and the Grants(current US$) in Mauritius in 1978?
Give a very brief answer. 2.51e+06. What is the difference between the Grants(current US$) of Mauritania in 1975 and the Grants(current US$) of Nepal in 1978?
Provide a succinct answer. -1.94e+07. What is the difference between the Grants(current US$) in Mauritania in 1975 and the Grants(current US$) in Uganda in 1978?
Give a very brief answer. -1.12e+06. What is the difference between the Grants(current US$) of Mauritius in 1975 and the Grants(current US$) of Nepal in 1978?
Your response must be concise. -2.38e+07. What is the difference between the Grants(current US$) of Mauritius in 1975 and the Grants(current US$) of Uganda in 1978?
Provide a succinct answer. -5.50e+06. What is the difference between the Grants(current US$) in Nepal in 1975 and the Grants(current US$) in Uganda in 1978?
Provide a succinct answer. 1.16e+07. What is the difference between the Grants(current US$) of Mauritania in 1975 and the Grants(current US$) of Mauritius in 1979?
Make the answer very short. 8.00e+05. What is the difference between the Grants(current US$) in Mauritania in 1975 and the Grants(current US$) in Nepal in 1979?
Provide a succinct answer. -2.48e+07. What is the difference between the Grants(current US$) in Mauritania in 1975 and the Grants(current US$) in Uganda in 1979?
Offer a terse response. -6.03e+06. What is the difference between the Grants(current US$) of Mauritius in 1975 and the Grants(current US$) of Nepal in 1979?
Your response must be concise. -2.92e+07. What is the difference between the Grants(current US$) in Mauritius in 1975 and the Grants(current US$) in Uganda in 1979?
Offer a very short reply. -1.04e+07. What is the difference between the Grants(current US$) in Nepal in 1975 and the Grants(current US$) in Uganda in 1979?
Give a very brief answer. 6.71e+06. What is the difference between the Grants(current US$) in Mauritania in 1976 and the Grants(current US$) in Mauritius in 1977?
Provide a succinct answer. 5.34e+06. What is the difference between the Grants(current US$) of Mauritania in 1976 and the Grants(current US$) of Nepal in 1977?
Offer a very short reply. -1.22e+07. What is the difference between the Grants(current US$) in Mauritania in 1976 and the Grants(current US$) in Uganda in 1977?
Provide a short and direct response. 3.95e+06. What is the difference between the Grants(current US$) of Mauritius in 1976 and the Grants(current US$) of Nepal in 1977?
Keep it short and to the point. -1.73e+07. What is the difference between the Grants(current US$) in Mauritius in 1976 and the Grants(current US$) in Uganda in 1977?
Give a very brief answer. -1.14e+06. What is the difference between the Grants(current US$) in Nepal in 1976 and the Grants(current US$) in Uganda in 1977?
Keep it short and to the point. 1.26e+07. What is the difference between the Grants(current US$) in Mauritania in 1976 and the Grants(current US$) in Mauritius in 1978?
Your answer should be very brief. 3.53e+06. What is the difference between the Grants(current US$) in Mauritania in 1976 and the Grants(current US$) in Nepal in 1978?
Offer a very short reply. -1.84e+07. What is the difference between the Grants(current US$) of Mauritania in 1976 and the Grants(current US$) of Uganda in 1978?
Offer a very short reply. -1.00e+05. What is the difference between the Grants(current US$) in Mauritius in 1976 and the Grants(current US$) in Nepal in 1978?
Your answer should be very brief. -2.35e+07. What is the difference between the Grants(current US$) of Mauritius in 1976 and the Grants(current US$) of Uganda in 1978?
Your answer should be very brief. -5.19e+06. What is the difference between the Grants(current US$) of Nepal in 1976 and the Grants(current US$) of Uganda in 1978?
Provide a short and direct response. 8.51e+06. What is the difference between the Grants(current US$) in Mauritania in 1976 and the Grants(current US$) in Mauritius in 1979?
Your response must be concise. 1.82e+06. What is the difference between the Grants(current US$) in Mauritania in 1976 and the Grants(current US$) in Nepal in 1979?
Your answer should be very brief. -2.38e+07. What is the difference between the Grants(current US$) in Mauritania in 1976 and the Grants(current US$) in Uganda in 1979?
Provide a succinct answer. -5.01e+06. What is the difference between the Grants(current US$) in Mauritius in 1976 and the Grants(current US$) in Nepal in 1979?
Ensure brevity in your answer.  -2.89e+07. What is the difference between the Grants(current US$) in Mauritius in 1976 and the Grants(current US$) in Uganda in 1979?
Provide a succinct answer. -1.01e+07. What is the difference between the Grants(current US$) in Nepal in 1976 and the Grants(current US$) in Uganda in 1979?
Your answer should be compact. 3.60e+06. What is the difference between the Grants(current US$) in Mauritania in 1977 and the Grants(current US$) in Mauritius in 1978?
Ensure brevity in your answer.  5.06e+06. What is the difference between the Grants(current US$) in Mauritania in 1977 and the Grants(current US$) in Nepal in 1978?
Your response must be concise. -1.68e+07. What is the difference between the Grants(current US$) of Mauritania in 1977 and the Grants(current US$) of Uganda in 1978?
Give a very brief answer. 1.43e+06. What is the difference between the Grants(current US$) in Mauritius in 1977 and the Grants(current US$) in Nepal in 1978?
Offer a very short reply. -2.37e+07. What is the difference between the Grants(current US$) of Mauritius in 1977 and the Grants(current US$) of Uganda in 1978?
Provide a short and direct response. -5.44e+06. What is the difference between the Grants(current US$) of Nepal in 1977 and the Grants(current US$) of Uganda in 1978?
Your answer should be compact. 1.21e+07. What is the difference between the Grants(current US$) in Mauritania in 1977 and the Grants(current US$) in Mauritius in 1979?
Your response must be concise. 3.35e+06. What is the difference between the Grants(current US$) of Mauritania in 1977 and the Grants(current US$) of Nepal in 1979?
Offer a very short reply. -2.22e+07. What is the difference between the Grants(current US$) in Mauritania in 1977 and the Grants(current US$) in Uganda in 1979?
Give a very brief answer. -3.48e+06. What is the difference between the Grants(current US$) of Mauritius in 1977 and the Grants(current US$) of Nepal in 1979?
Ensure brevity in your answer.  -2.91e+07. What is the difference between the Grants(current US$) of Mauritius in 1977 and the Grants(current US$) of Uganda in 1979?
Provide a succinct answer. -1.04e+07. What is the difference between the Grants(current US$) of Nepal in 1977 and the Grants(current US$) of Uganda in 1979?
Your answer should be very brief. 7.18e+06. What is the difference between the Grants(current US$) in Mauritania in 1978 and the Grants(current US$) in Mauritius in 1979?
Provide a succinct answer. 5.83e+06. What is the difference between the Grants(current US$) of Mauritania in 1978 and the Grants(current US$) of Nepal in 1979?
Keep it short and to the point. -1.98e+07. What is the difference between the Grants(current US$) of Mauritius in 1978 and the Grants(current US$) of Nepal in 1979?
Give a very brief answer. -2.73e+07. What is the difference between the Grants(current US$) of Mauritius in 1978 and the Grants(current US$) of Uganda in 1979?
Give a very brief answer. -8.54e+06. What is the difference between the Grants(current US$) in Nepal in 1978 and the Grants(current US$) in Uganda in 1979?
Provide a short and direct response. 1.34e+07. What is the average Grants(current US$) of Mauritania per year?
Give a very brief answer. 1.21e+07. What is the average Grants(current US$) in Mauritius per year?
Provide a succinct answer. 5.97e+06. What is the average Grants(current US$) in Nepal per year?
Your answer should be very brief. 2.09e+07. What is the average Grants(current US$) of Uganda per year?
Your answer should be compact. 1.08e+07. In the year 1972, what is the difference between the Grants(current US$) of Mauritania and Grants(current US$) of Mauritius?
Your answer should be compact. 2.88e+06. In the year 1972, what is the difference between the Grants(current US$) of Mauritania and Grants(current US$) of Nepal?
Provide a succinct answer. -3.85e+06. In the year 1972, what is the difference between the Grants(current US$) of Mauritania and Grants(current US$) of Uganda?
Offer a terse response. -9.81e+06. In the year 1972, what is the difference between the Grants(current US$) of Mauritius and Grants(current US$) of Nepal?
Provide a short and direct response. -6.73e+06. In the year 1972, what is the difference between the Grants(current US$) of Mauritius and Grants(current US$) of Uganda?
Your response must be concise. -1.27e+07. In the year 1972, what is the difference between the Grants(current US$) of Nepal and Grants(current US$) of Uganda?
Your answer should be very brief. -5.96e+06. In the year 1973, what is the difference between the Grants(current US$) of Mauritania and Grants(current US$) of Mauritius?
Provide a succinct answer. 3.38e+06. In the year 1973, what is the difference between the Grants(current US$) in Mauritania and Grants(current US$) in Nepal?
Offer a very short reply. -4.66e+06. In the year 1973, what is the difference between the Grants(current US$) in Mauritania and Grants(current US$) in Uganda?
Make the answer very short. -3.97e+06. In the year 1973, what is the difference between the Grants(current US$) of Mauritius and Grants(current US$) of Nepal?
Your response must be concise. -8.04e+06. In the year 1973, what is the difference between the Grants(current US$) in Mauritius and Grants(current US$) in Uganda?
Ensure brevity in your answer.  -7.35e+06. In the year 1973, what is the difference between the Grants(current US$) in Nepal and Grants(current US$) in Uganda?
Provide a short and direct response. 6.90e+05. In the year 1974, what is the difference between the Grants(current US$) in Mauritania and Grants(current US$) in Mauritius?
Offer a terse response. 4.81e+06. In the year 1974, what is the difference between the Grants(current US$) of Mauritania and Grants(current US$) of Nepal?
Offer a terse response. -3.99e+06. In the year 1974, what is the difference between the Grants(current US$) in Mauritania and Grants(current US$) in Uganda?
Offer a terse response. 1.76e+06. In the year 1974, what is the difference between the Grants(current US$) of Mauritius and Grants(current US$) of Nepal?
Ensure brevity in your answer.  -8.80e+06. In the year 1974, what is the difference between the Grants(current US$) in Mauritius and Grants(current US$) in Uganda?
Ensure brevity in your answer.  -3.05e+06. In the year 1974, what is the difference between the Grants(current US$) of Nepal and Grants(current US$) of Uganda?
Offer a very short reply. 5.75e+06. In the year 1975, what is the difference between the Grants(current US$) in Mauritania and Grants(current US$) in Mauritius?
Ensure brevity in your answer.  4.38e+06. In the year 1975, what is the difference between the Grants(current US$) of Mauritania and Grants(current US$) of Nepal?
Keep it short and to the point. -1.27e+07. In the year 1975, what is the difference between the Grants(current US$) in Mauritania and Grants(current US$) in Uganda?
Offer a very short reply. 1.93e+06. In the year 1975, what is the difference between the Grants(current US$) in Mauritius and Grants(current US$) in Nepal?
Offer a very short reply. -1.71e+07. In the year 1975, what is the difference between the Grants(current US$) of Mauritius and Grants(current US$) of Uganda?
Give a very brief answer. -2.45e+06. In the year 1975, what is the difference between the Grants(current US$) in Nepal and Grants(current US$) in Uganda?
Your answer should be compact. 1.47e+07. In the year 1976, what is the difference between the Grants(current US$) of Mauritania and Grants(current US$) of Mauritius?
Keep it short and to the point. 5.09e+06. In the year 1976, what is the difference between the Grants(current US$) in Mauritania and Grants(current US$) in Nepal?
Give a very brief answer. -8.61e+06. In the year 1976, what is the difference between the Grants(current US$) in Mauritania and Grants(current US$) in Uganda?
Your answer should be compact. 4.15e+06. In the year 1976, what is the difference between the Grants(current US$) in Mauritius and Grants(current US$) in Nepal?
Ensure brevity in your answer.  -1.37e+07. In the year 1976, what is the difference between the Grants(current US$) in Mauritius and Grants(current US$) in Uganda?
Keep it short and to the point. -9.40e+05. In the year 1976, what is the difference between the Grants(current US$) in Nepal and Grants(current US$) in Uganda?
Make the answer very short. 1.28e+07. In the year 1977, what is the difference between the Grants(current US$) in Mauritania and Grants(current US$) in Mauritius?
Give a very brief answer. 6.87e+06. In the year 1977, what is the difference between the Grants(current US$) in Mauritania and Grants(current US$) in Nepal?
Keep it short and to the point. -1.07e+07. In the year 1977, what is the difference between the Grants(current US$) of Mauritania and Grants(current US$) of Uganda?
Make the answer very short. 5.48e+06. In the year 1977, what is the difference between the Grants(current US$) in Mauritius and Grants(current US$) in Nepal?
Your response must be concise. -1.75e+07. In the year 1977, what is the difference between the Grants(current US$) of Mauritius and Grants(current US$) of Uganda?
Keep it short and to the point. -1.39e+06. In the year 1977, what is the difference between the Grants(current US$) in Nepal and Grants(current US$) in Uganda?
Your response must be concise. 1.61e+07. In the year 1978, what is the difference between the Grants(current US$) in Mauritania and Grants(current US$) in Mauritius?
Give a very brief answer. 7.54e+06. In the year 1978, what is the difference between the Grants(current US$) in Mauritania and Grants(current US$) in Nepal?
Your response must be concise. -1.44e+07. In the year 1978, what is the difference between the Grants(current US$) in Mauritania and Grants(current US$) in Uganda?
Keep it short and to the point. 3.91e+06. In the year 1978, what is the difference between the Grants(current US$) in Mauritius and Grants(current US$) in Nepal?
Your response must be concise. -2.19e+07. In the year 1978, what is the difference between the Grants(current US$) of Mauritius and Grants(current US$) of Uganda?
Ensure brevity in your answer.  -3.63e+06. In the year 1978, what is the difference between the Grants(current US$) of Nepal and Grants(current US$) of Uganda?
Make the answer very short. 1.83e+07. In the year 1979, what is the difference between the Grants(current US$) in Mauritania and Grants(current US$) in Mauritius?
Your response must be concise. 1.40e+07. In the year 1979, what is the difference between the Grants(current US$) in Mauritania and Grants(current US$) in Nepal?
Provide a short and direct response. -1.16e+07. In the year 1979, what is the difference between the Grants(current US$) of Mauritania and Grants(current US$) of Uganda?
Keep it short and to the point. 7.14e+06. In the year 1979, what is the difference between the Grants(current US$) in Mauritius and Grants(current US$) in Nepal?
Give a very brief answer. -2.56e+07. In the year 1979, what is the difference between the Grants(current US$) of Mauritius and Grants(current US$) of Uganda?
Make the answer very short. -6.83e+06. In the year 1979, what is the difference between the Grants(current US$) of Nepal and Grants(current US$) of Uganda?
Ensure brevity in your answer.  1.88e+07. What is the ratio of the Grants(current US$) in Mauritania in 1972 to that in 1973?
Your answer should be compact. 0.79. What is the ratio of the Grants(current US$) of Mauritius in 1972 to that in 1973?
Make the answer very short. 0.75. What is the ratio of the Grants(current US$) in Nepal in 1972 to that in 1973?
Offer a terse response. 0.8. What is the ratio of the Grants(current US$) in Uganda in 1972 to that in 1973?
Provide a succinct answer. 1.36. What is the ratio of the Grants(current US$) in Mauritania in 1972 to that in 1974?
Provide a short and direct response. 0.63. What is the ratio of the Grants(current US$) in Mauritius in 1972 to that in 1974?
Your response must be concise. 0.67. What is the ratio of the Grants(current US$) of Nepal in 1972 to that in 1974?
Your answer should be compact. 0.73. What is the ratio of the Grants(current US$) of Uganda in 1972 to that in 1974?
Offer a very short reply. 1.99. What is the ratio of the Grants(current US$) in Mauritania in 1972 to that in 1975?
Offer a very short reply. 0.61. What is the ratio of the Grants(current US$) of Mauritius in 1972 to that in 1975?
Keep it short and to the point. 0.57. What is the ratio of the Grants(current US$) of Nepal in 1972 to that in 1975?
Your answer should be very brief. 0.44. What is the ratio of the Grants(current US$) in Uganda in 1972 to that in 1975?
Your answer should be very brief. 1.93. What is the ratio of the Grants(current US$) in Mauritania in 1972 to that in 1976?
Keep it short and to the point. 0.55. What is the ratio of the Grants(current US$) of Mauritius in 1972 to that in 1976?
Provide a succinct answer. 0.54. What is the ratio of the Grants(current US$) of Nepal in 1972 to that in 1976?
Offer a very short reply. 0.51. What is the ratio of the Grants(current US$) in Uganda in 1972 to that in 1976?
Ensure brevity in your answer.  2.26. What is the ratio of the Grants(current US$) of Mauritania in 1972 to that in 1977?
Your answer should be very brief. 0.49. What is the ratio of the Grants(current US$) in Mauritius in 1972 to that in 1977?
Your response must be concise. 0.56. What is the ratio of the Grants(current US$) of Nepal in 1972 to that in 1977?
Provide a short and direct response. 0.43. What is the ratio of the Grants(current US$) in Uganda in 1972 to that in 1977?
Keep it short and to the point. 2.2. What is the ratio of the Grants(current US$) in Mauritania in 1972 to that in 1978?
Keep it short and to the point. 0.41. What is the ratio of the Grants(current US$) in Mauritius in 1972 to that in 1978?
Your answer should be compact. 0.43. What is the ratio of the Grants(current US$) of Nepal in 1972 to that in 1978?
Make the answer very short. 0.34. What is the ratio of the Grants(current US$) in Uganda in 1972 to that in 1978?
Provide a succinct answer. 1.41. What is the ratio of the Grants(current US$) in Mauritania in 1972 to that in 1979?
Provide a succinct answer. 0.27. What is the ratio of the Grants(current US$) in Mauritius in 1972 to that in 1979?
Your answer should be compact. 0.35. What is the ratio of the Grants(current US$) of Nepal in 1972 to that in 1979?
Offer a very short reply. 0.29. What is the ratio of the Grants(current US$) in Uganda in 1972 to that in 1979?
Your response must be concise. 0.99. What is the ratio of the Grants(current US$) of Mauritania in 1973 to that in 1974?
Offer a terse response. 0.8. What is the ratio of the Grants(current US$) of Mauritius in 1973 to that in 1974?
Your answer should be compact. 0.89. What is the ratio of the Grants(current US$) of Nepal in 1973 to that in 1974?
Provide a short and direct response. 0.91. What is the ratio of the Grants(current US$) of Uganda in 1973 to that in 1974?
Keep it short and to the point. 1.47. What is the ratio of the Grants(current US$) in Mauritania in 1973 to that in 1975?
Offer a very short reply. 0.77. What is the ratio of the Grants(current US$) in Mauritius in 1973 to that in 1975?
Keep it short and to the point. 0.76. What is the ratio of the Grants(current US$) in Nepal in 1973 to that in 1975?
Make the answer very short. 0.54. What is the ratio of the Grants(current US$) in Uganda in 1973 to that in 1975?
Offer a terse response. 1.42. What is the ratio of the Grants(current US$) in Mauritania in 1973 to that in 1976?
Ensure brevity in your answer.  0.7. What is the ratio of the Grants(current US$) in Mauritius in 1973 to that in 1976?
Offer a very short reply. 0.72. What is the ratio of the Grants(current US$) in Nepal in 1973 to that in 1976?
Offer a very short reply. 0.63. What is the ratio of the Grants(current US$) in Uganda in 1973 to that in 1976?
Give a very brief answer. 1.66. What is the ratio of the Grants(current US$) in Mauritania in 1973 to that in 1977?
Your answer should be compact. 0.61. What is the ratio of the Grants(current US$) of Mauritius in 1973 to that in 1977?
Your answer should be compact. 0.75. What is the ratio of the Grants(current US$) of Nepal in 1973 to that in 1977?
Provide a succinct answer. 0.53. What is the ratio of the Grants(current US$) of Uganda in 1973 to that in 1977?
Keep it short and to the point. 1.62. What is the ratio of the Grants(current US$) in Mauritania in 1973 to that in 1978?
Ensure brevity in your answer.  0.51. What is the ratio of the Grants(current US$) of Mauritius in 1973 to that in 1978?
Make the answer very short. 0.58. What is the ratio of the Grants(current US$) of Nepal in 1973 to that in 1978?
Offer a terse response. 0.42. What is the ratio of the Grants(current US$) of Uganda in 1973 to that in 1978?
Give a very brief answer. 1.04. What is the ratio of the Grants(current US$) of Mauritania in 1973 to that in 1979?
Offer a terse response. 0.33. What is the ratio of the Grants(current US$) in Mauritius in 1973 to that in 1979?
Ensure brevity in your answer.  0.47. What is the ratio of the Grants(current US$) of Nepal in 1973 to that in 1979?
Keep it short and to the point. 0.36. What is the ratio of the Grants(current US$) in Uganda in 1973 to that in 1979?
Offer a very short reply. 0.73. What is the ratio of the Grants(current US$) in Mauritania in 1974 to that in 1975?
Keep it short and to the point. 0.96. What is the ratio of the Grants(current US$) of Mauritius in 1974 to that in 1975?
Your answer should be very brief. 0.85. What is the ratio of the Grants(current US$) in Nepal in 1974 to that in 1975?
Make the answer very short. 0.6. What is the ratio of the Grants(current US$) of Uganda in 1974 to that in 1975?
Offer a terse response. 0.97. What is the ratio of the Grants(current US$) of Mauritania in 1974 to that in 1976?
Make the answer very short. 0.87. What is the ratio of the Grants(current US$) in Mauritius in 1974 to that in 1976?
Offer a terse response. 0.81. What is the ratio of the Grants(current US$) in Nepal in 1974 to that in 1976?
Your answer should be compact. 0.69. What is the ratio of the Grants(current US$) of Uganda in 1974 to that in 1976?
Provide a short and direct response. 1.13. What is the ratio of the Grants(current US$) in Mauritania in 1974 to that in 1977?
Offer a very short reply. 0.77. What is the ratio of the Grants(current US$) of Mauritius in 1974 to that in 1977?
Keep it short and to the point. 0.84. What is the ratio of the Grants(current US$) of Nepal in 1974 to that in 1977?
Offer a terse response. 0.59. What is the ratio of the Grants(current US$) of Uganda in 1974 to that in 1977?
Provide a succinct answer. 1.1. What is the ratio of the Grants(current US$) of Mauritania in 1974 to that in 1978?
Give a very brief answer. 0.64. What is the ratio of the Grants(current US$) in Mauritius in 1974 to that in 1978?
Make the answer very short. 0.65. What is the ratio of the Grants(current US$) in Nepal in 1974 to that in 1978?
Make the answer very short. 0.47. What is the ratio of the Grants(current US$) of Uganda in 1974 to that in 1978?
Keep it short and to the point. 0.71. What is the ratio of the Grants(current US$) in Mauritania in 1974 to that in 1979?
Ensure brevity in your answer.  0.42. What is the ratio of the Grants(current US$) in Mauritius in 1974 to that in 1979?
Provide a succinct answer. 0.53. What is the ratio of the Grants(current US$) of Nepal in 1974 to that in 1979?
Your response must be concise. 0.39. What is the ratio of the Grants(current US$) in Uganda in 1974 to that in 1979?
Make the answer very short. 0.49. What is the ratio of the Grants(current US$) of Mauritania in 1975 to that in 1976?
Offer a terse response. 0.91. What is the ratio of the Grants(current US$) in Mauritius in 1975 to that in 1976?
Your answer should be compact. 0.95. What is the ratio of the Grants(current US$) of Nepal in 1975 to that in 1976?
Keep it short and to the point. 1.16. What is the ratio of the Grants(current US$) in Uganda in 1975 to that in 1976?
Your answer should be very brief. 1.17. What is the ratio of the Grants(current US$) of Mauritania in 1975 to that in 1977?
Keep it short and to the point. 0.8. What is the ratio of the Grants(current US$) in Mauritius in 1975 to that in 1977?
Provide a succinct answer. 0.99. What is the ratio of the Grants(current US$) of Nepal in 1975 to that in 1977?
Give a very brief answer. 0.98. What is the ratio of the Grants(current US$) in Uganda in 1975 to that in 1977?
Make the answer very short. 1.14. What is the ratio of the Grants(current US$) of Mauritania in 1975 to that in 1978?
Your answer should be compact. 0.67. What is the ratio of the Grants(current US$) in Mauritius in 1975 to that in 1978?
Ensure brevity in your answer.  0.76. What is the ratio of the Grants(current US$) in Nepal in 1975 to that in 1978?
Ensure brevity in your answer.  0.78. What is the ratio of the Grants(current US$) of Uganda in 1975 to that in 1978?
Make the answer very short. 0.73. What is the ratio of the Grants(current US$) of Mauritania in 1975 to that in 1979?
Your response must be concise. 0.44. What is the ratio of the Grants(current US$) in Mauritius in 1975 to that in 1979?
Your answer should be very brief. 0.62. What is the ratio of the Grants(current US$) in Nepal in 1975 to that in 1979?
Provide a succinct answer. 0.66. What is the ratio of the Grants(current US$) in Uganda in 1975 to that in 1979?
Your response must be concise. 0.51. What is the ratio of the Grants(current US$) in Mauritania in 1976 to that in 1977?
Your answer should be very brief. 0.88. What is the ratio of the Grants(current US$) in Mauritius in 1976 to that in 1977?
Keep it short and to the point. 1.04. What is the ratio of the Grants(current US$) of Nepal in 1976 to that in 1977?
Keep it short and to the point. 0.85. What is the ratio of the Grants(current US$) in Uganda in 1976 to that in 1977?
Keep it short and to the point. 0.97. What is the ratio of the Grants(current US$) of Mauritania in 1976 to that in 1978?
Provide a succinct answer. 0.74. What is the ratio of the Grants(current US$) of Mauritius in 1976 to that in 1978?
Ensure brevity in your answer.  0.8. What is the ratio of the Grants(current US$) of Nepal in 1976 to that in 1978?
Your answer should be very brief. 0.67. What is the ratio of the Grants(current US$) in Uganda in 1976 to that in 1978?
Give a very brief answer. 0.63. What is the ratio of the Grants(current US$) of Mauritania in 1976 to that in 1979?
Your answer should be very brief. 0.48. What is the ratio of the Grants(current US$) of Mauritius in 1976 to that in 1979?
Keep it short and to the point. 0.65. What is the ratio of the Grants(current US$) in Nepal in 1976 to that in 1979?
Your response must be concise. 0.57. What is the ratio of the Grants(current US$) of Uganda in 1976 to that in 1979?
Make the answer very short. 0.44. What is the ratio of the Grants(current US$) in Mauritania in 1977 to that in 1978?
Make the answer very short. 0.84. What is the ratio of the Grants(current US$) of Mauritius in 1977 to that in 1978?
Offer a very short reply. 0.77. What is the ratio of the Grants(current US$) in Nepal in 1977 to that in 1978?
Provide a succinct answer. 0.79. What is the ratio of the Grants(current US$) of Uganda in 1977 to that in 1978?
Give a very brief answer. 0.64. What is the ratio of the Grants(current US$) of Mauritania in 1977 to that in 1979?
Provide a succinct answer. 0.55. What is the ratio of the Grants(current US$) of Mauritius in 1977 to that in 1979?
Ensure brevity in your answer.  0.63. What is the ratio of the Grants(current US$) of Nepal in 1977 to that in 1979?
Your answer should be compact. 0.67. What is the ratio of the Grants(current US$) in Uganda in 1977 to that in 1979?
Make the answer very short. 0.45. What is the ratio of the Grants(current US$) of Mauritania in 1978 to that in 1979?
Make the answer very short. 0.65. What is the ratio of the Grants(current US$) of Mauritius in 1978 to that in 1979?
Provide a succinct answer. 0.82. What is the ratio of the Grants(current US$) of Nepal in 1978 to that in 1979?
Your response must be concise. 0.85. What is the ratio of the Grants(current US$) of Uganda in 1978 to that in 1979?
Provide a short and direct response. 0.7. What is the difference between the highest and the second highest Grants(current US$) of Mauritania?
Offer a very short reply. 8.14e+06. What is the difference between the highest and the second highest Grants(current US$) in Mauritius?
Keep it short and to the point. 1.71e+06. What is the difference between the highest and the second highest Grants(current US$) of Nepal?
Provide a succinct answer. 5.40e+06. What is the difference between the highest and the lowest Grants(current US$) of Mauritania?
Your answer should be compact. 1.72e+07. What is the difference between the highest and the lowest Grants(current US$) in Mauritius?
Keep it short and to the point. 6.10e+06. What is the difference between the highest and the lowest Grants(current US$) of Nepal?
Give a very brief answer. 2.50e+07. What is the difference between the highest and the lowest Grants(current US$) of Uganda?
Provide a short and direct response. 9.16e+06. 